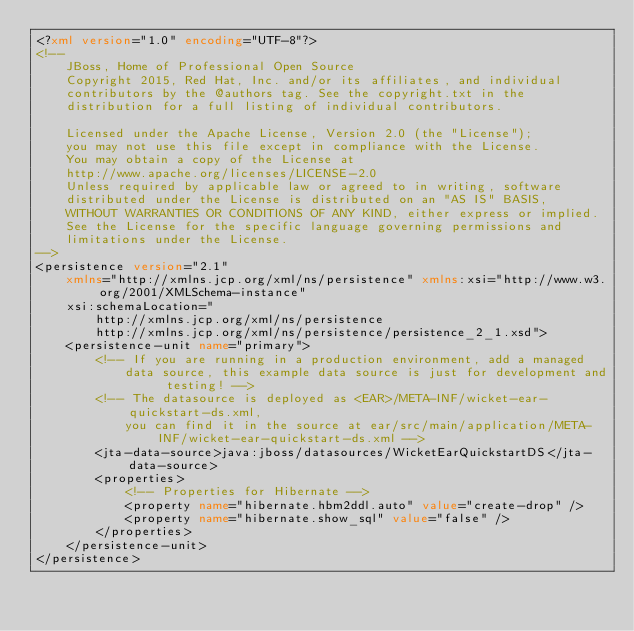Convert code to text. <code><loc_0><loc_0><loc_500><loc_500><_XML_><?xml version="1.0" encoding="UTF-8"?>
<!--
    JBoss, Home of Professional Open Source
    Copyright 2015, Red Hat, Inc. and/or its affiliates, and individual
    contributors by the @authors tag. See the copyright.txt in the
    distribution for a full listing of individual contributors.

    Licensed under the Apache License, Version 2.0 (the "License");
    you may not use this file except in compliance with the License.
    You may obtain a copy of the License at
    http://www.apache.org/licenses/LICENSE-2.0
    Unless required by applicable law or agreed to in writing, software
    distributed under the License is distributed on an "AS IS" BASIS,
    WITHOUT WARRANTIES OR CONDITIONS OF ANY KIND, either express or implied.
    See the License for the specific language governing permissions and
    limitations under the License.
-->
<persistence version="2.1"
    xmlns="http://xmlns.jcp.org/xml/ns/persistence" xmlns:xsi="http://www.w3.org/2001/XMLSchema-instance"
    xsi:schemaLocation="
        http://xmlns.jcp.org/xml/ns/persistence
        http://xmlns.jcp.org/xml/ns/persistence/persistence_2_1.xsd">
    <persistence-unit name="primary">
        <!-- If you are running in a production environment, add a managed
            data source, this example data source is just for development and testing! -->
        <!-- The datasource is deployed as <EAR>/META-INF/wicket-ear-quickstart-ds.xml,
            you can find it in the source at ear/src/main/application/META-INF/wicket-ear-quickstart-ds.xml -->
        <jta-data-source>java:jboss/datasources/WicketEarQuickstartDS</jta-data-source>
        <properties>
            <!-- Properties for Hibernate -->
            <property name="hibernate.hbm2ddl.auto" value="create-drop" />
            <property name="hibernate.show_sql" value="false" />
        </properties>
    </persistence-unit>
</persistence>
</code> 